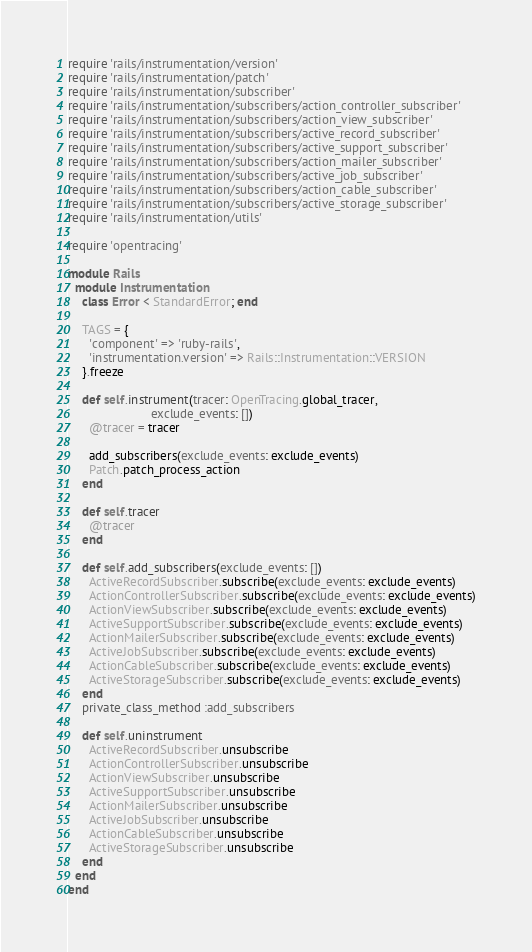Convert code to text. <code><loc_0><loc_0><loc_500><loc_500><_Ruby_>require 'rails/instrumentation/version'
require 'rails/instrumentation/patch'
require 'rails/instrumentation/subscriber'
require 'rails/instrumentation/subscribers/action_controller_subscriber'
require 'rails/instrumentation/subscribers/action_view_subscriber'
require 'rails/instrumentation/subscribers/active_record_subscriber'
require 'rails/instrumentation/subscribers/active_support_subscriber'
require 'rails/instrumentation/subscribers/action_mailer_subscriber'
require 'rails/instrumentation/subscribers/active_job_subscriber'
require 'rails/instrumentation/subscribers/action_cable_subscriber'
require 'rails/instrumentation/subscribers/active_storage_subscriber'
require 'rails/instrumentation/utils'

require 'opentracing'

module Rails
  module Instrumentation
    class Error < StandardError; end

    TAGS = {
      'component' => 'ruby-rails',
      'instrumentation.version' => Rails::Instrumentation::VERSION
    }.freeze

    def self.instrument(tracer: OpenTracing.global_tracer,
                        exclude_events: [])
      @tracer = tracer

      add_subscribers(exclude_events: exclude_events)
      Patch.patch_process_action
    end

    def self.tracer
      @tracer
    end

    def self.add_subscribers(exclude_events: [])
      ActiveRecordSubscriber.subscribe(exclude_events: exclude_events)
      ActionControllerSubscriber.subscribe(exclude_events: exclude_events)
      ActionViewSubscriber.subscribe(exclude_events: exclude_events)
      ActiveSupportSubscriber.subscribe(exclude_events: exclude_events)
      ActionMailerSubscriber.subscribe(exclude_events: exclude_events)
      ActiveJobSubscriber.subscribe(exclude_events: exclude_events)
      ActionCableSubscriber.subscribe(exclude_events: exclude_events)
      ActiveStorageSubscriber.subscribe(exclude_events: exclude_events)
    end
    private_class_method :add_subscribers

    def self.uninstrument
      ActiveRecordSubscriber.unsubscribe
      ActionControllerSubscriber.unsubscribe
      ActionViewSubscriber.unsubscribe
      ActiveSupportSubscriber.unsubscribe
      ActionMailerSubscriber.unsubscribe
      ActiveJobSubscriber.unsubscribe
      ActionCableSubscriber.unsubscribe
      ActiveStorageSubscriber.unsubscribe
    end
  end
end
</code> 